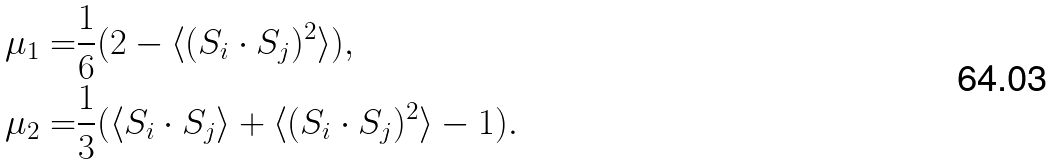Convert formula to latex. <formula><loc_0><loc_0><loc_500><loc_500>\mu _ { 1 } = & \frac { 1 } 6 ( 2 - \langle ( { S } _ { i } \cdot { S } _ { j } ) ^ { 2 } \rangle ) , \\ \mu _ { 2 } = & \frac { 1 } 3 ( \langle { S } _ { i } \cdot { S } _ { j } \rangle + \langle ( { S } _ { i } \cdot { S } _ { j } ) ^ { 2 } \rangle - 1 ) .</formula> 